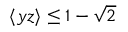<formula> <loc_0><loc_0><loc_500><loc_500>\langle y z \rangle \leq 1 - \sqrt { 2 }</formula> 